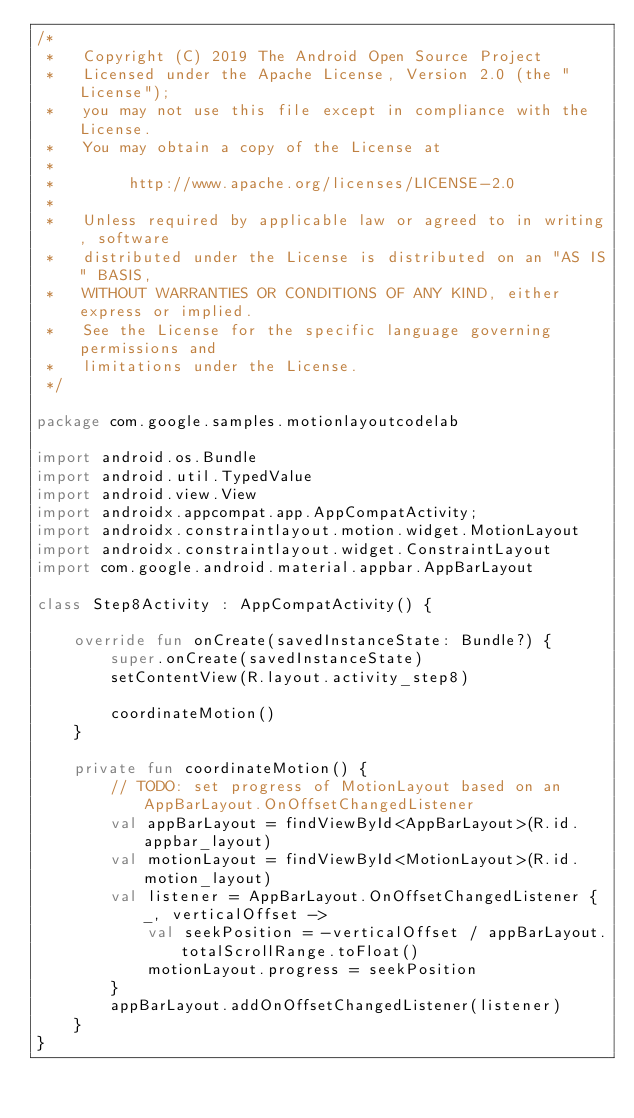Convert code to text. <code><loc_0><loc_0><loc_500><loc_500><_Kotlin_>/*
 *   Copyright (C) 2019 The Android Open Source Project
 *   Licensed under the Apache License, Version 2.0 (the "License");
 *   you may not use this file except in compliance with the License.
 *   You may obtain a copy of the License at
 *
 *        http://www.apache.org/licenses/LICENSE-2.0
 *
 *   Unless required by applicable law or agreed to in writing, software
 *   distributed under the License is distributed on an "AS IS" BASIS,
 *   WITHOUT WARRANTIES OR CONDITIONS OF ANY KIND, either express or implied.
 *   See the License for the specific language governing permissions and
 *   limitations under the License.
 */

package com.google.samples.motionlayoutcodelab

import android.os.Bundle
import android.util.TypedValue
import android.view.View
import androidx.appcompat.app.AppCompatActivity;
import androidx.constraintlayout.motion.widget.MotionLayout
import androidx.constraintlayout.widget.ConstraintLayout
import com.google.android.material.appbar.AppBarLayout

class Step8Activity : AppCompatActivity() {

    override fun onCreate(savedInstanceState: Bundle?) {
        super.onCreate(savedInstanceState)
        setContentView(R.layout.activity_step8)

        coordinateMotion()
    }

    private fun coordinateMotion() {
        // TODO: set progress of MotionLayout based on an AppBarLayout.OnOffsetChangedListener
        val appBarLayout = findViewById<AppBarLayout>(R.id.appbar_layout)
        val motionLayout = findViewById<MotionLayout>(R.id.motion_layout)
        val listener = AppBarLayout.OnOffsetChangedListener { _, verticalOffset ->
            val seekPosition = -verticalOffset / appBarLayout.totalScrollRange.toFloat()
            motionLayout.progress = seekPosition
        }
        appBarLayout.addOnOffsetChangedListener(listener)
    }
}
</code> 